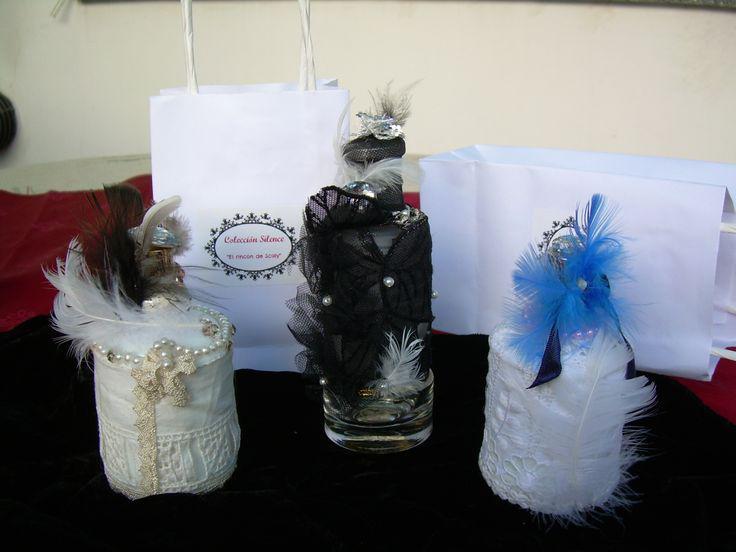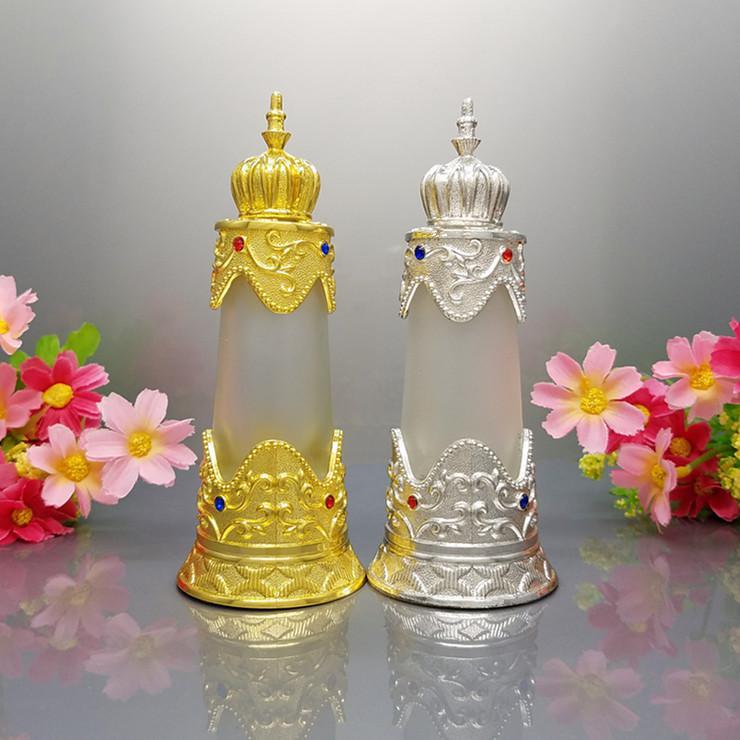The first image is the image on the left, the second image is the image on the right. Evaluate the accuracy of this statement regarding the images: "There are two containers in one of the images.". Is it true? Answer yes or no. Yes. The first image is the image on the left, the second image is the image on the right. Considering the images on both sides, is "An image shows at least two decorative bottles flanked by flowers, and the bottles feature different metallic colors partly wrapping semi-translucent glass." valid? Answer yes or no. Yes. 